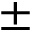<formula> <loc_0><loc_0><loc_500><loc_500>\pm</formula> 